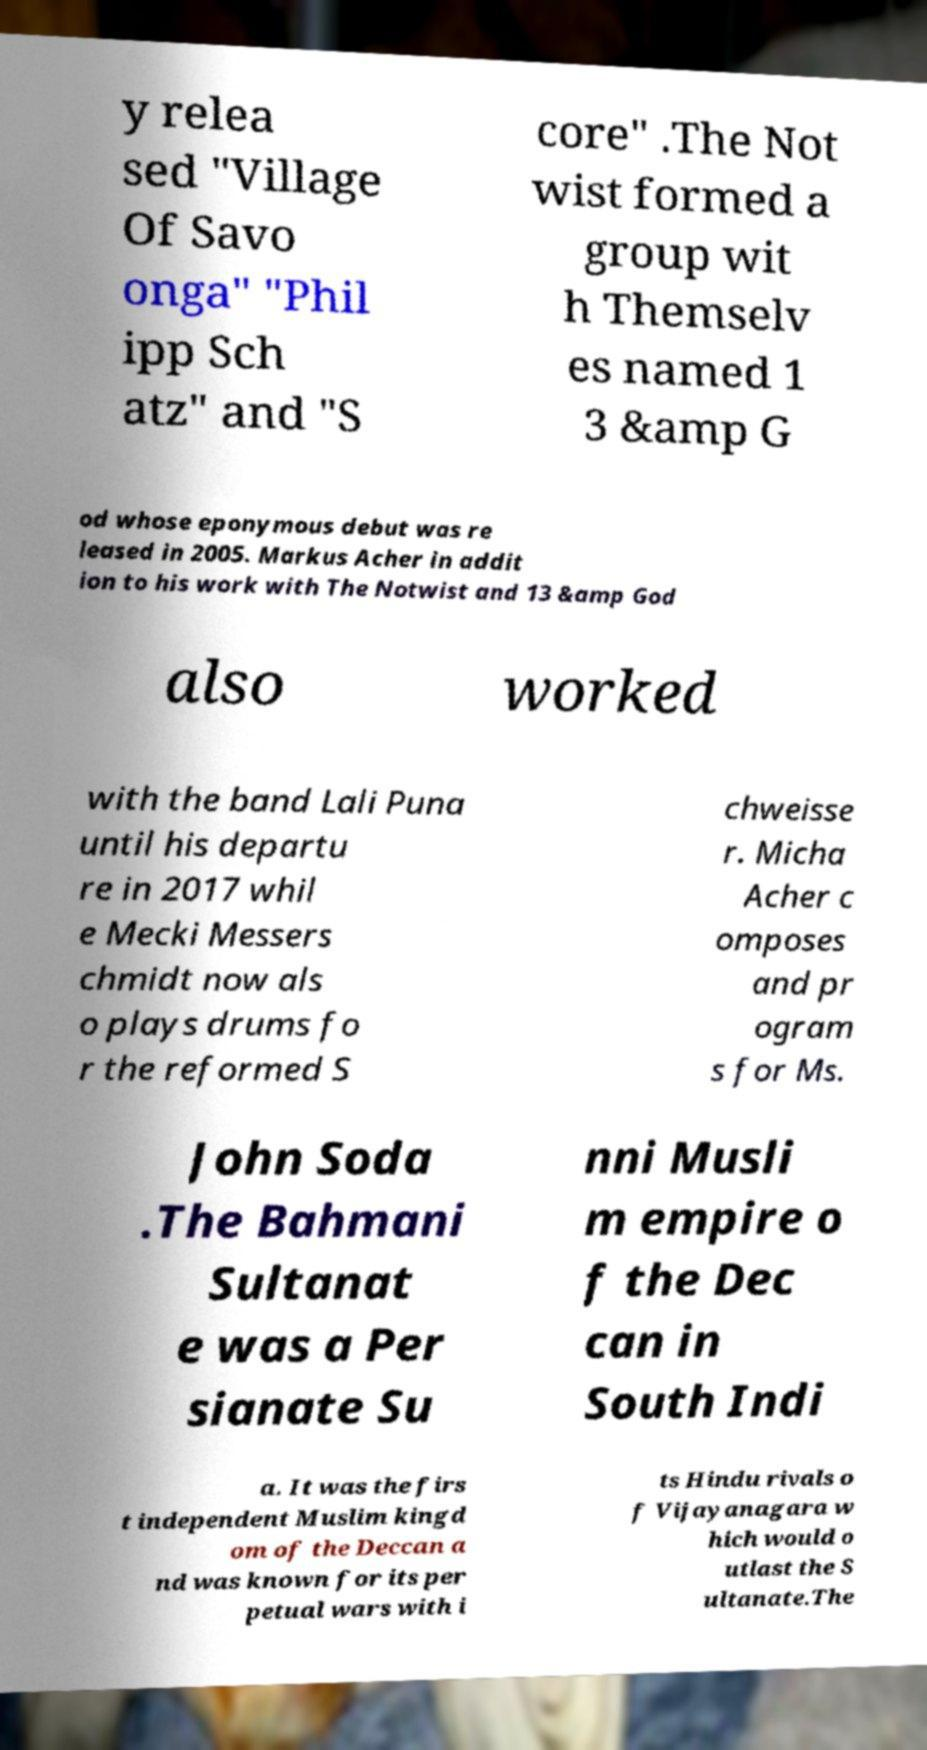What messages or text are displayed in this image? I need them in a readable, typed format. y relea sed "Village Of Savo onga" "Phil ipp Sch atz" and "S core" .The Not wist formed a group wit h Themselv es named 1 3 &amp G od whose eponymous debut was re leased in 2005. Markus Acher in addit ion to his work with The Notwist and 13 &amp God also worked with the band Lali Puna until his departu re in 2017 whil e Mecki Messers chmidt now als o plays drums fo r the reformed S chweisse r. Micha Acher c omposes and pr ogram s for Ms. John Soda .The Bahmani Sultanat e was a Per sianate Su nni Musli m empire o f the Dec can in South Indi a. It was the firs t independent Muslim kingd om of the Deccan a nd was known for its per petual wars with i ts Hindu rivals o f Vijayanagara w hich would o utlast the S ultanate.The 